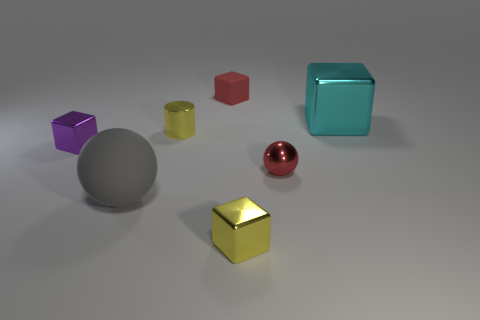Subtract all red blocks. How many blocks are left? 3 Add 1 big purple matte cylinders. How many objects exist? 8 Subtract all cylinders. How many objects are left? 6 Add 5 big cyan metallic blocks. How many big cyan metallic blocks exist? 6 Subtract 0 brown blocks. How many objects are left? 7 Subtract all large yellow shiny spheres. Subtract all yellow things. How many objects are left? 5 Add 2 red rubber things. How many red rubber things are left? 3 